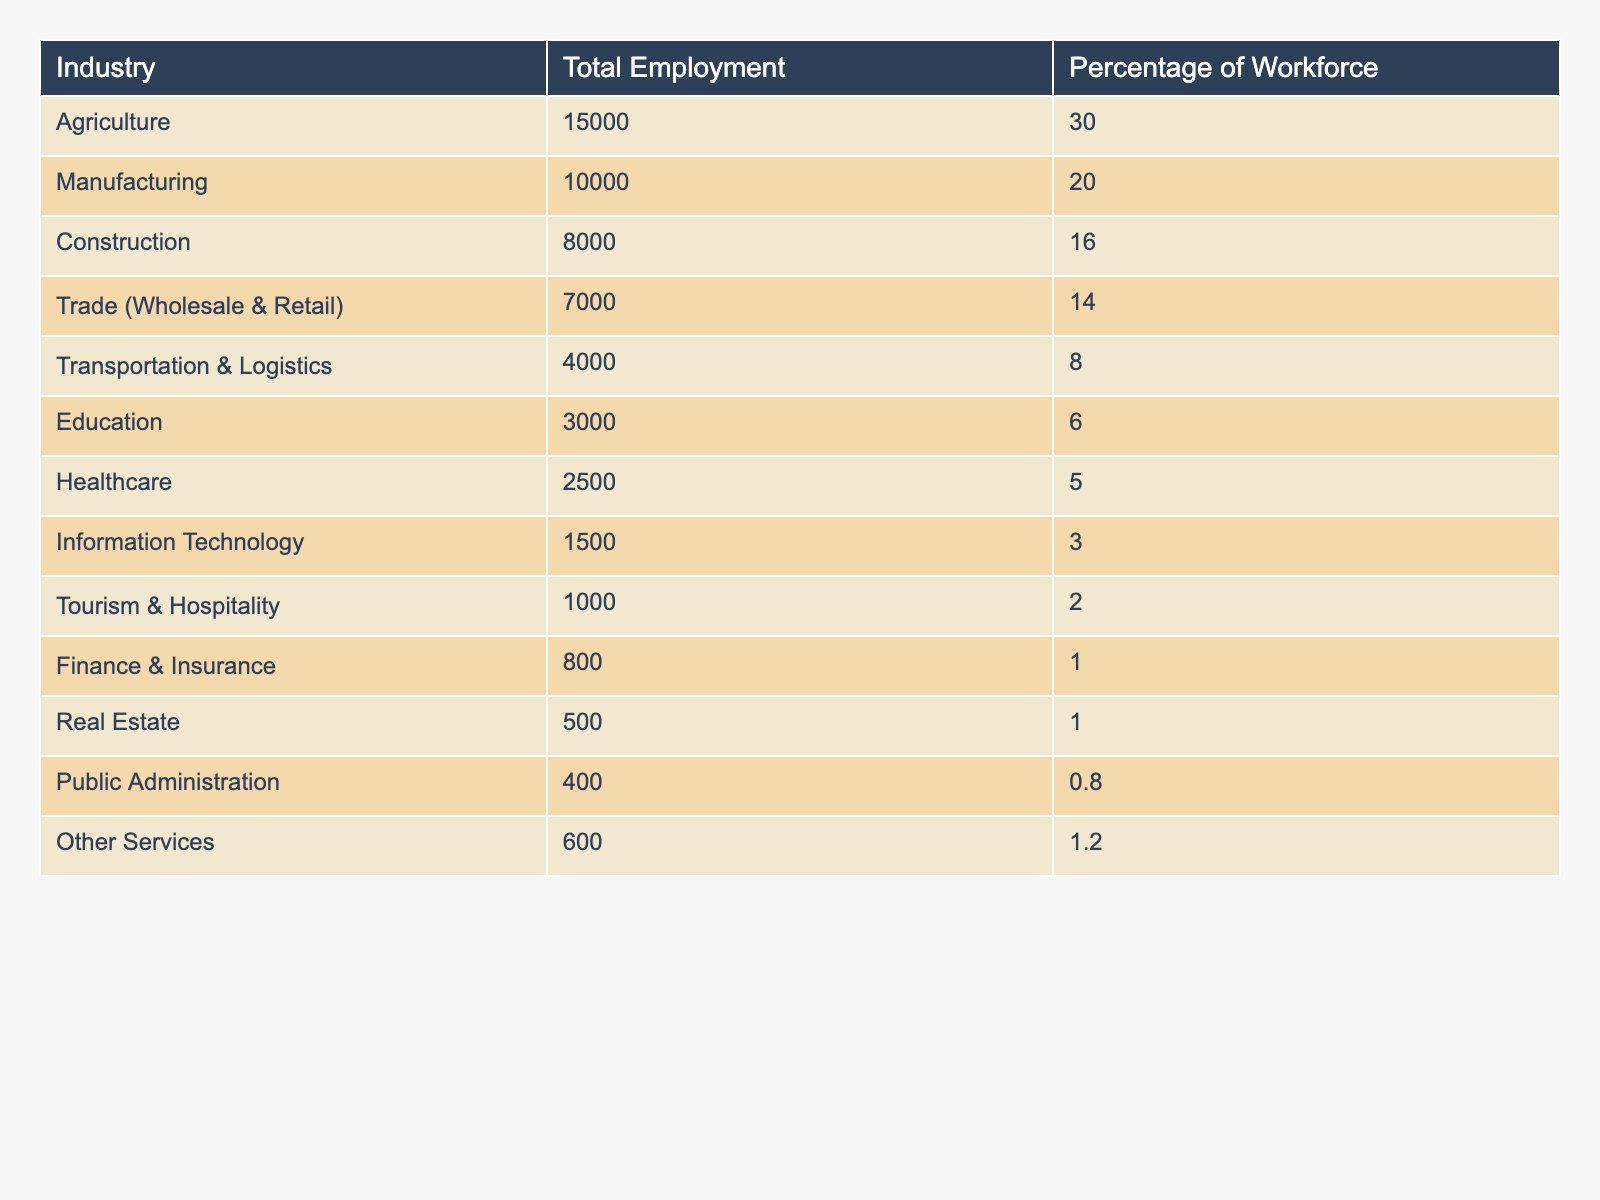What industry has the highest total employment in Shivamogga City? Looking at the table, Agriculture has the highest total employment with 15,000 workers.
Answer: Agriculture What percentage of the workforce is employed in Information Technology? The table shows that Information Technology employs 3% of the workforce.
Answer: 3% How many people are employed in Construction? The table indicates that there are 8,000 people employed in Construction.
Answer: 8000 What is the total number of people employed in Trade and Transportation combined? To find the total, we add the employment in Trade (7,000) and Transportation (4,000): 7,000 + 4,000 = 11,000.
Answer: 11000 Which two industries have a combined total employment of less than 5,000? By checking the table, both Finance & Insurance (800) and Real Estate (500) sum up to 1,300, which is less than 5,000.
Answer: Finance & Insurance and Real Estate Is the total employment in Healthcare higher than in Education? The table shows Healthcare has 2,500 employees, and Education has 3,000; thus, Healthcare is not higher than Education.
Answer: No What percentage of the workforce is employed in Agriculture compared to Healthcare? Agriculture employs 30% of the workforce and Healthcare employs 5%. The difference is 30% - 5% = 25%.
Answer: 25% What industry has the lowest employment, and what is the percentage of the workforce? According to the table, Real Estate has the lowest employment at 500, which is 1% of the workforce.
Answer: Real Estate, 1% What is the difference in employment between the Manufacturing and Trade industries? Manufacturing has 10,000 and Trade has 7,000 employees. The difference is 10,000 - 7,000 = 3,000.
Answer: 3000 If we combine the employment in Public Administration and Other Services, do they exceed 1,000? Public Administration has 400 and Other Services has 600; their total is 400 + 600 = 1,000, which does not exceed 1,000.
Answer: No 